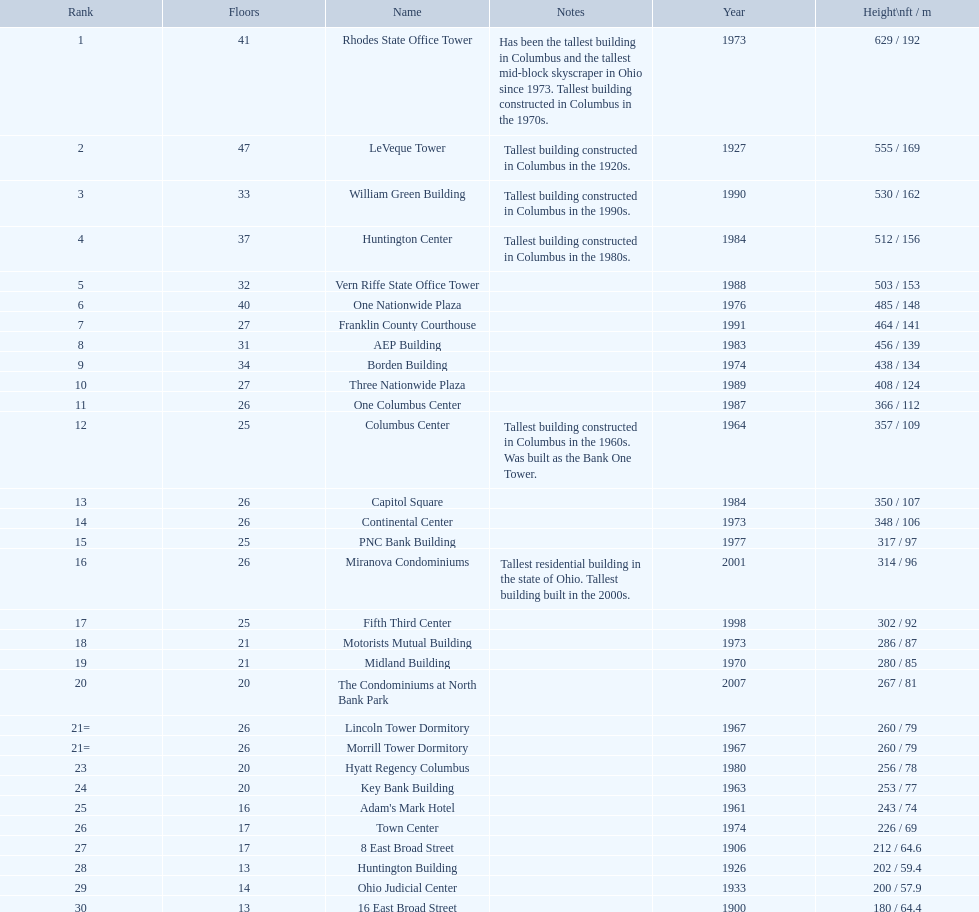How tall is the aep building? 456 / 139. How tall is the one columbus center? 366 / 112. Of these two buildings, which is taller? AEP Building. 